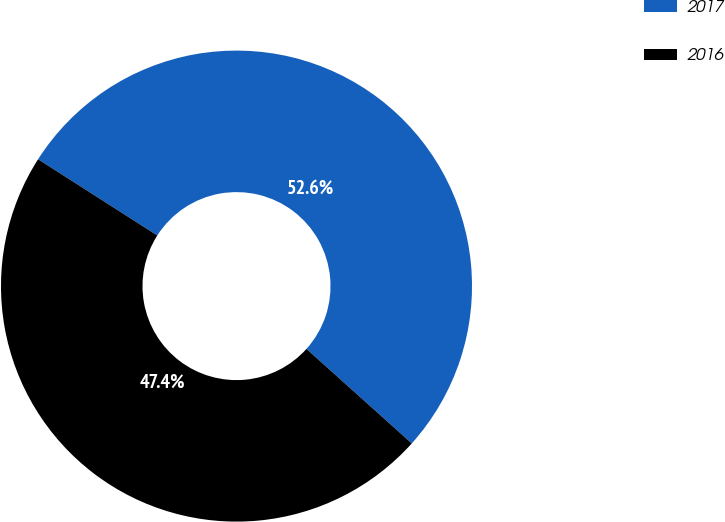Convert chart to OTSL. <chart><loc_0><loc_0><loc_500><loc_500><pie_chart><fcel>2017<fcel>2016<nl><fcel>52.59%<fcel>47.41%<nl></chart> 